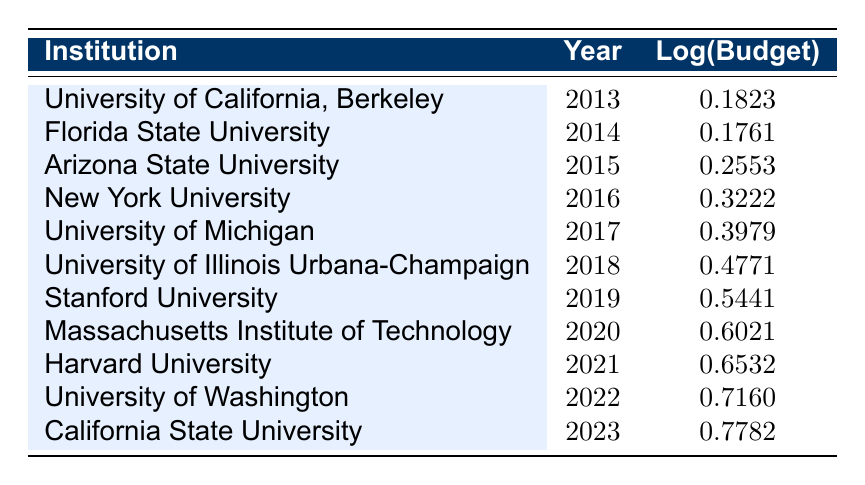What was the budget allocation for Stanford University in 2019? The table directly provides the budget allocation for Stanford University in 2019, which is listed under that institution and year.
Answer: 3.5 million USD What is the log value for the budget allocation in 2020? The log value for the budget allocation in 2020 can be found directly in the row for the Massachusetts Institute of Technology, which shows 0.6021 as the log value.
Answer: 0.6021 Which institution had the highest budget allocation in the table? Reviewing the budget allocations listed, California State University in 2023 has the highest budget allocation at 6.0 million USD.
Answer: California State University What is the total budget allocation (in million USD) for all institutions in 2019 and 2020 combined? First, find the budget allocations for both 2019 and 2020: Stanford University for 2019 has 3.5 million USD and MIT for 2020 has 4.0 million USD. Then, sum them: 3.5 + 4.0 = 7.5 million USD.
Answer: 7.5 million USD Was the budget allocation for University of Michigan in 2017 greater than that of Florida State University in 2014? Comparing the allocations, University of Michigan has 2.5 million USD in 2017, while Florida State University has 1.5 million USD in 2014. Since 2.5 is greater than 1.5, the statement is true.
Answer: Yes What is the average budget allocation over the decade presented in the table? To find the average, sum the budget allocations from 2013 to 2023: (1.2 + 1.5 + 1.8 + 2.1 + 2.5 + 3.0 + 3.5 + 4.0 + 4.5 + 5.2 + 6.0) = 31.8 million USD. Then, divide by the number of entries (11): 31.8 / 11 ≈ 2.89 million USD.
Answer: Approximately 2.89 million USD Is the budget allocation for Harvard University in 2021 more than the average allocation from 2013 to 2022? Calculate the average for 2013 to 2022: sum (1.2 + 1.5 + 1.8 + 2.1 + 2.5 + 3.0 + 3.5 + 4.0 + 4.5 + 5.2) = 28.8 million; average = 28.8 / 10 = 2.88 million USD. Harvard’s budget of 4.5 million USD in 2021 is indeed more than 2.88.
Answer: Yes What is the trend in budget allocation growth from 2013 to 2023? By examining the budgets year by year, it can be observed that the allocation increases consistently each year from 1.2 million USD in 2013 to 6.0 million USD in 2023, indicating a clear upward trend.
Answer: Increasing trend 